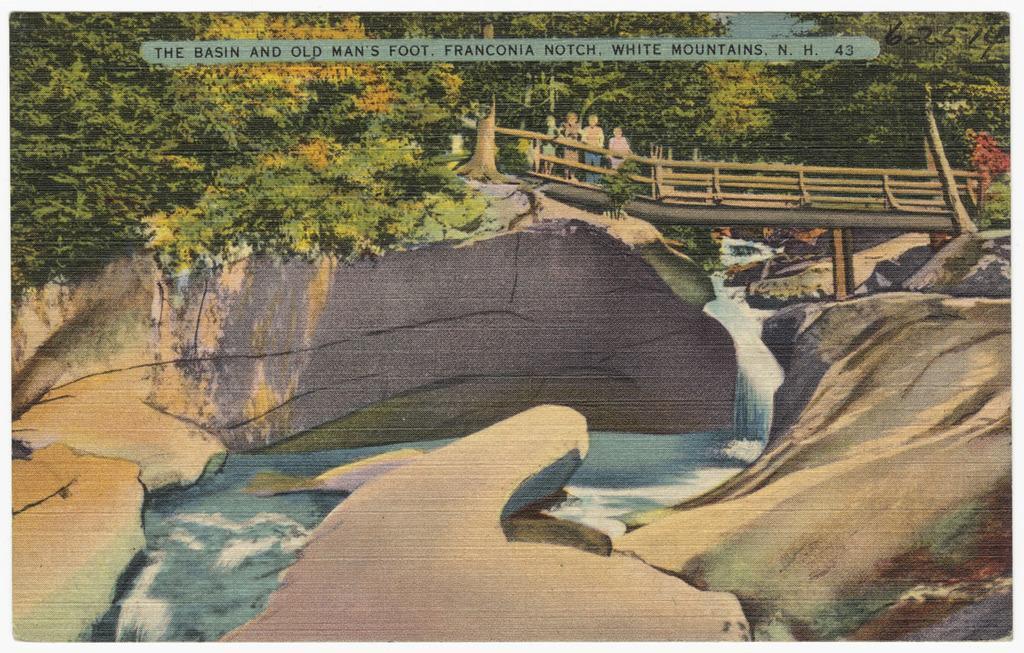Can you describe this image briefly? In this image we can see a painting of a group of persons standing on a bridge, water, a group of trees and some text on it. 